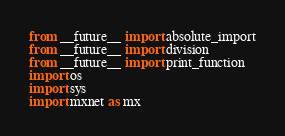<code> <loc_0><loc_0><loc_500><loc_500><_Python_>from __future__ import absolute_import
from __future__ import division
from __future__ import print_function
import os
import sys
import mxnet as mx</code> 